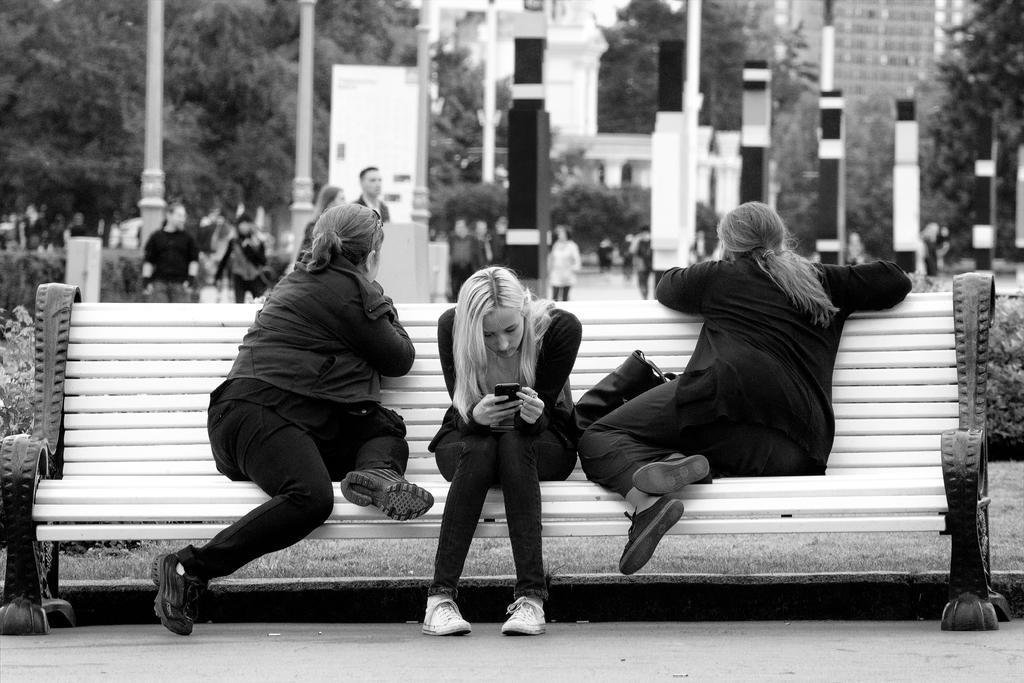In one or two sentences, can you explain what this image depicts? Black and white picture. Front these 3 women are sitting on a bench. This woman is holding a mobile. Far these persons are standing and we can able to see buildings, trees and poles. 